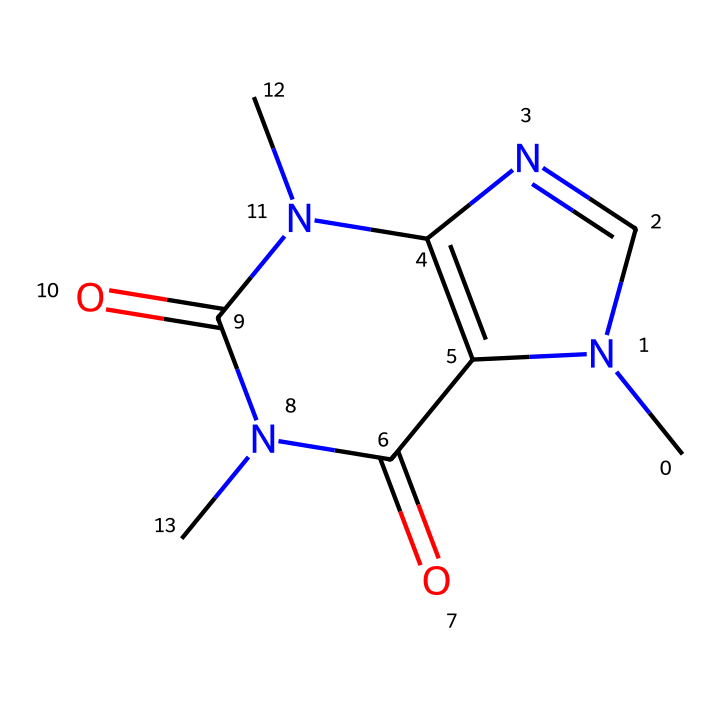What is the molecular formula of caffeine? To determine the molecular formula, we count the types and number of atoms in the chemical structure. In the SMILES representation, C is carbon, N is nitrogen, and O is oxygen. By analyzing the structure, we find there are 8 carbon atoms, 10 hydrogen atoms, 4 nitrogen atoms, and 2 oxygen atoms. Thus, the molecular formula is C8H10N4O2.
Answer: C8H10N4O2 How many nitrogen atoms are present in caffeine? By examining the SMILES representation, we can identify the nitrogen atoms (N). The count shows there are 4 nitrogen atoms in the chemical structure.
Answer: 4 What is the functional group of caffeine that contributes to its stimulant properties? In caffeine, the presence of the nitrogen atoms suggests it is an alkaloid. Alkaloids are known for their stimulant effects. The nitrogen groups, particularly the amine functional groups, contribute to these properties.
Answer: alkaloid What type of compound is caffeine classified as? The structure contains nitrogen atoms, and it is derived from purine bases found in nucleotides, which classify it as an alkaloid. Thus, caffeine is classified as an alkaloid compound.
Answer: alkaloid Does caffeine contain any double bonds? In the given SMILES structure, we can observe the presence of double bond characters (depicted by the "=" signs in the representation), indicating that there are indeed double bonds present in the molecule.
Answer: yes 